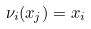<formula> <loc_0><loc_0><loc_500><loc_500>\nu _ { i } ( x _ { j } ) = x _ { i }</formula> 